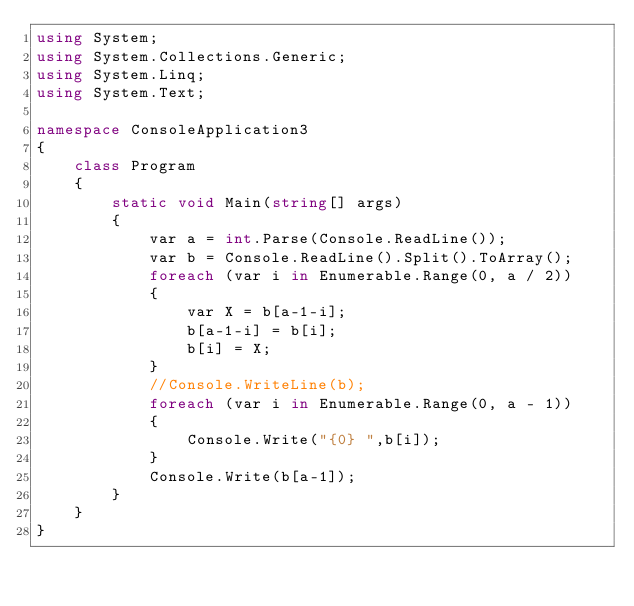<code> <loc_0><loc_0><loc_500><loc_500><_C#_>using System;
using System.Collections.Generic;
using System.Linq;
using System.Text;

namespace ConsoleApplication3
{
    class Program
    {
        static void Main(string[] args)
        {
            var a = int.Parse(Console.ReadLine());
            var b = Console.ReadLine().Split().ToArray();
            foreach (var i in Enumerable.Range(0, a / 2))
            {
                var X = b[a-1-i];
                b[a-1-i] = b[i];
                b[i] = X;
            }
            //Console.WriteLine(b);
            foreach (var i in Enumerable.Range(0, a - 1))
            {
                Console.Write("{0} ",b[i]);
            }
            Console.Write(b[a-1]);
        }
    }
}</code> 